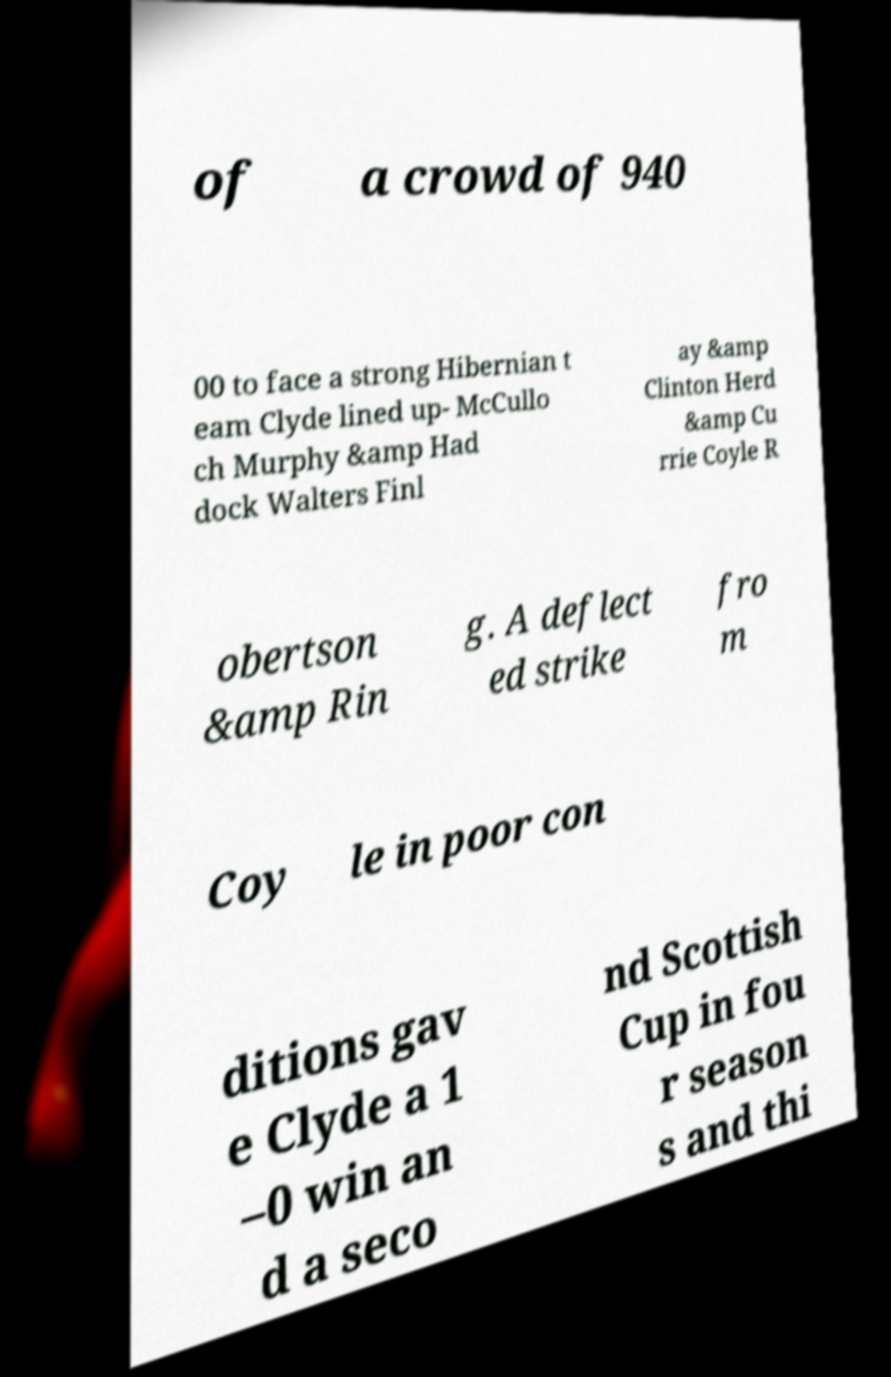I need the written content from this picture converted into text. Can you do that? of a crowd of 940 00 to face a strong Hibernian t eam Clyde lined up- McCullo ch Murphy &amp Had dock Walters Finl ay &amp Clinton Herd &amp Cu rrie Coyle R obertson &amp Rin g. A deflect ed strike fro m Coy le in poor con ditions gav e Clyde a 1 –0 win an d a seco nd Scottish Cup in fou r season s and thi 